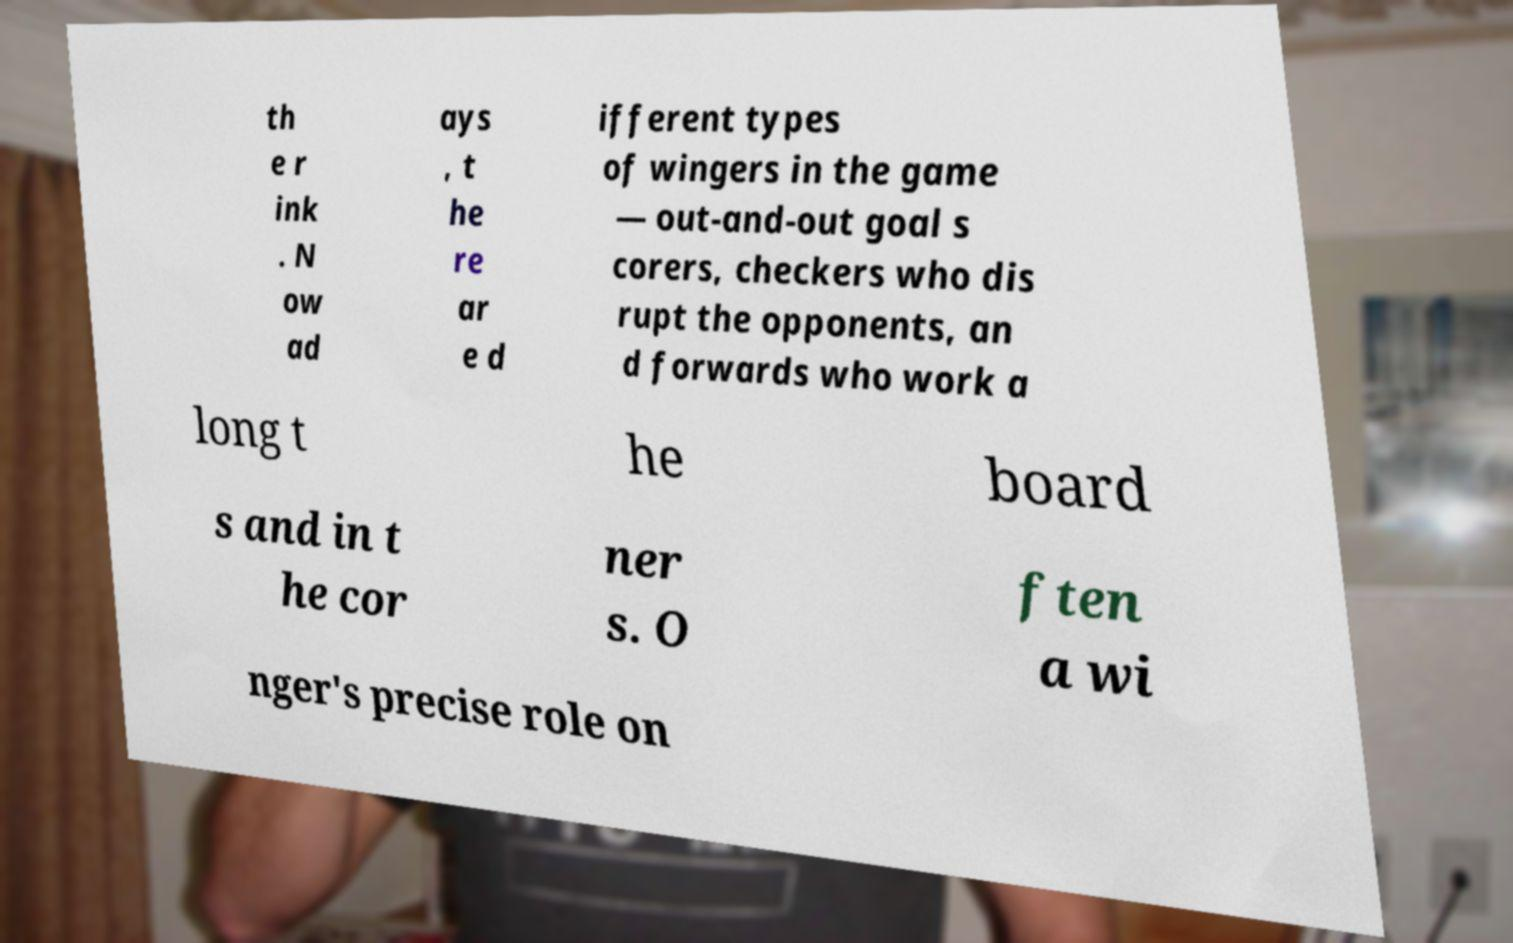I need the written content from this picture converted into text. Can you do that? th e r ink . N ow ad ays , t he re ar e d ifferent types of wingers in the game — out-and-out goal s corers, checkers who dis rupt the opponents, an d forwards who work a long t he board s and in t he cor ner s. O ften a wi nger's precise role on 